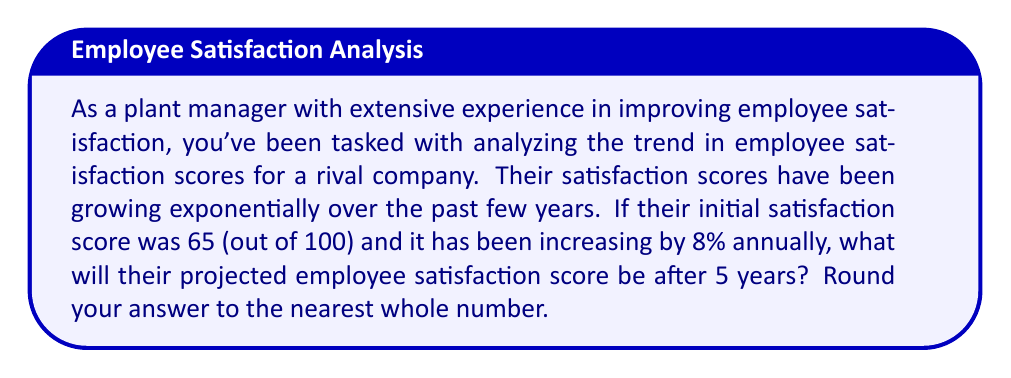Provide a solution to this math problem. To solve this problem, we'll use the exponential growth model:

$$A = P(1 + r)^t$$

Where:
$A$ = Final amount
$P$ = Initial amount (principal)
$r$ = Growth rate (as a decimal)
$t$ = Time period

Given:
$P = 65$ (initial satisfaction score)
$r = 0.08$ (8% annual growth rate)
$t = 5$ years

Let's plug these values into our formula:

$$A = 65(1 + 0.08)^5$$

Now, let's solve step-by-step:

1) First, calculate $(1 + 0.08)^5$:
   $$(1.08)^5 = 1.46933...$$

2) Now multiply this by the initial score:
   $$65 \times 1.46933... = 95.50645...$$

3) Rounding to the nearest whole number:
   $$95.50645... \approx 96$$

Therefore, the projected employee satisfaction score after 5 years will be approximately 96 out of 100.
Answer: 96 